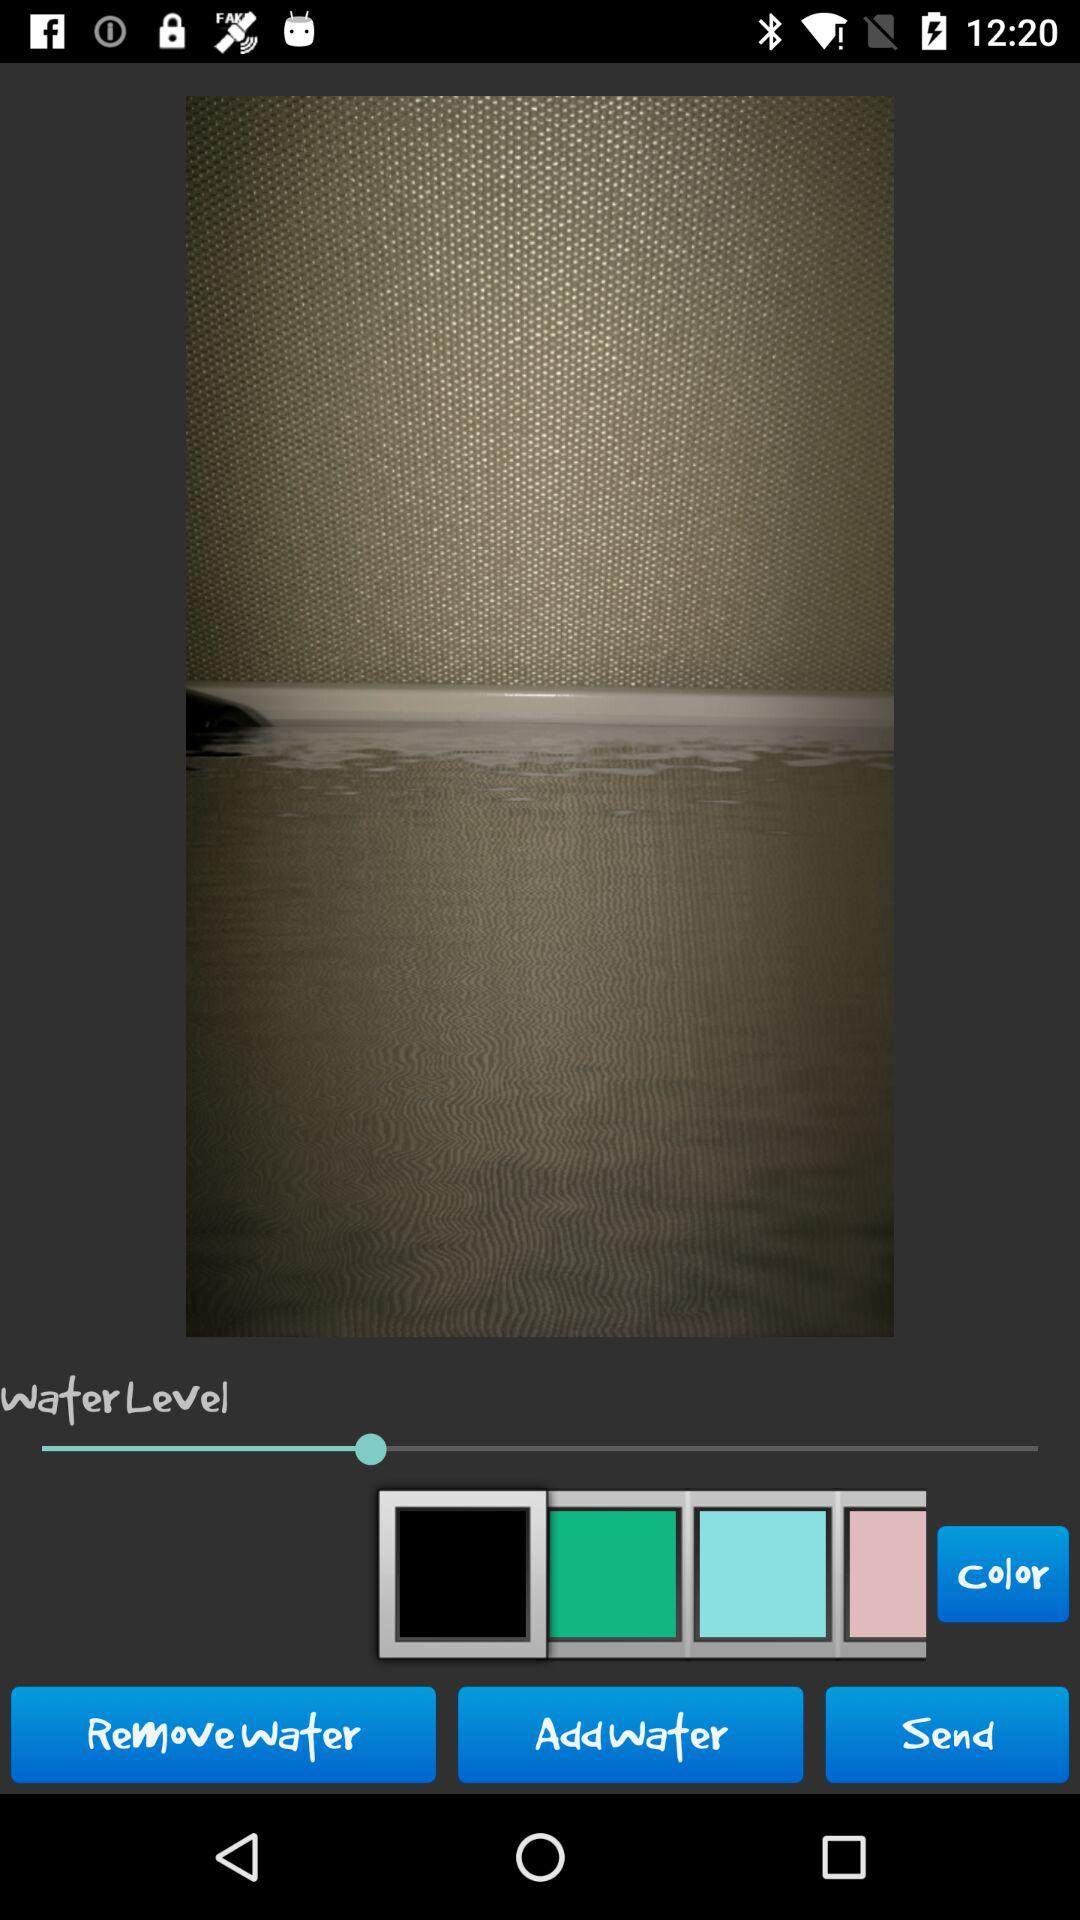How many colors are there in the row of colored blocks?
Answer the question using a single word or phrase. 4 